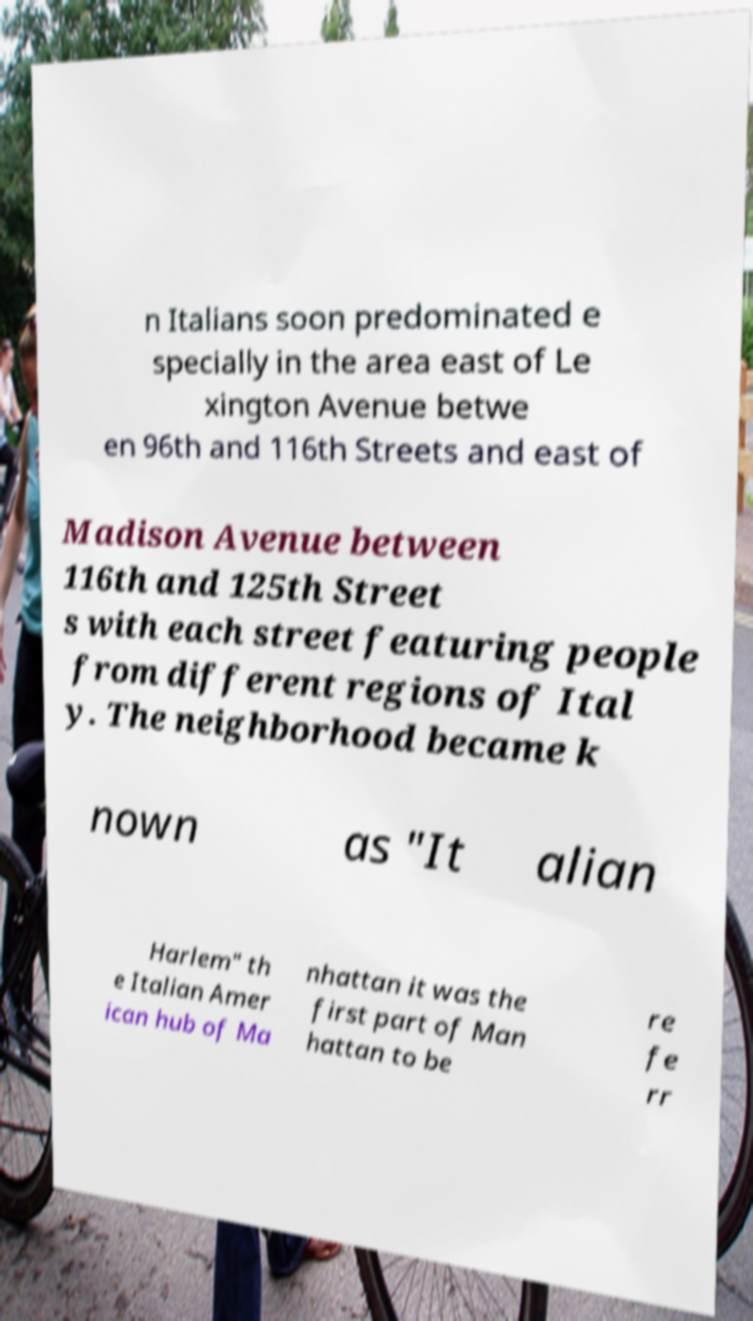Could you extract and type out the text from this image? n Italians soon predominated e specially in the area east of Le xington Avenue betwe en 96th and 116th Streets and east of Madison Avenue between 116th and 125th Street s with each street featuring people from different regions of Ital y. The neighborhood became k nown as "It alian Harlem" th e Italian Amer ican hub of Ma nhattan it was the first part of Man hattan to be re fe rr 